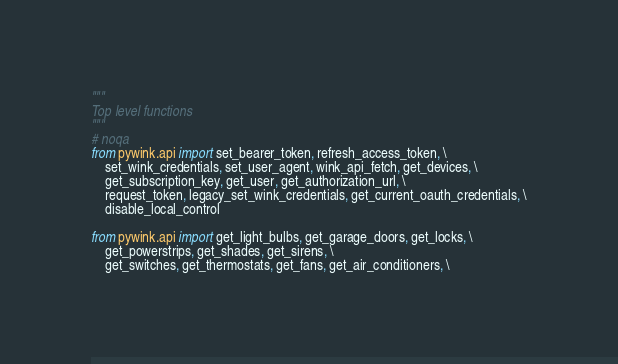<code> <loc_0><loc_0><loc_500><loc_500><_Python_>"""
Top level functions
"""
# noqa
from pywink.api import set_bearer_token, refresh_access_token, \
    set_wink_credentials, set_user_agent, wink_api_fetch, get_devices, \
    get_subscription_key, get_user, get_authorization_url, \
    request_token, legacy_set_wink_credentials, get_current_oauth_credentials, \
    disable_local_control

from pywink.api import get_light_bulbs, get_garage_doors, get_locks, \
    get_powerstrips, get_shades, get_sirens, \
    get_switches, get_thermostats, get_fans, get_air_conditioners, \</code> 